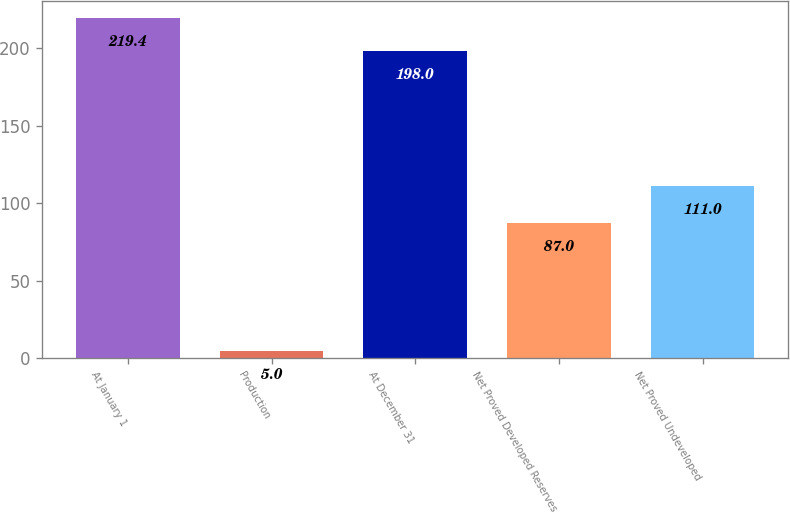Convert chart to OTSL. <chart><loc_0><loc_0><loc_500><loc_500><bar_chart><fcel>At January 1<fcel>Production<fcel>At December 31<fcel>Net Proved Developed Reserves<fcel>Net Proved Undeveloped<nl><fcel>219.4<fcel>5<fcel>198<fcel>87<fcel>111<nl></chart> 